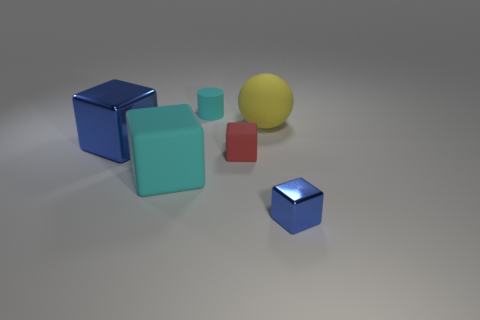The other shiny thing that is the same shape as the tiny shiny object is what size? The other object that appears to share the same cubic shape as the small shiny blue cube is in fact larger compared to the tiny one, though without specific measurements, it is not possible to provide an exact size. Based on the perspective in the image, the larger blue cube seems to be approximately twice the size of the smaller blue cube. 